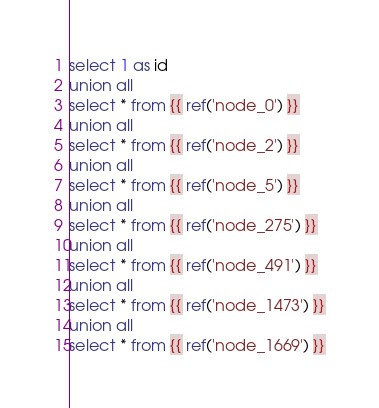<code> <loc_0><loc_0><loc_500><loc_500><_SQL_>select 1 as id
union all
select * from {{ ref('node_0') }}
union all
select * from {{ ref('node_2') }}
union all
select * from {{ ref('node_5') }}
union all
select * from {{ ref('node_275') }}
union all
select * from {{ ref('node_491') }}
union all
select * from {{ ref('node_1473') }}
union all
select * from {{ ref('node_1669') }}
</code> 